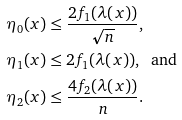Convert formula to latex. <formula><loc_0><loc_0><loc_500><loc_500>\eta _ { 0 } ( x ) & \leq \frac { 2 f _ { 1 } ( \lambda ( x ) ) } { \sqrt { n } } , \\ \eta _ { 1 } ( x ) & \leq 2 f _ { 1 } ( \lambda ( x ) ) , \ \text { and } \\ \eta _ { 2 } ( x ) & \leq \frac { 4 f _ { 2 } ( \lambda ( x ) ) } { n } .</formula> 